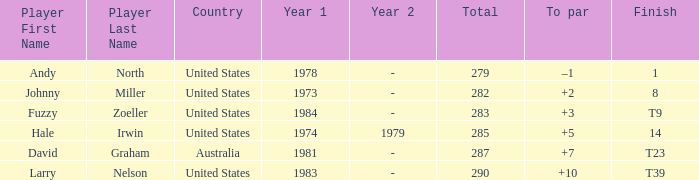Which player finished at +10? Larry Nelson. 